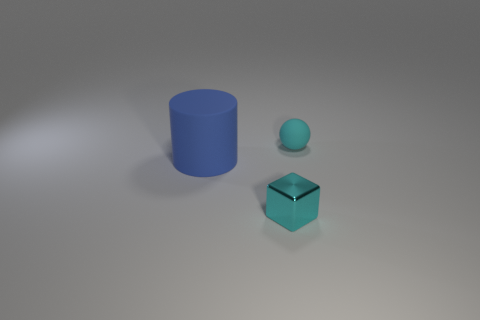How does the size of the blue cylinder compare to the other objects in the image? The blue cylinder is the largest object in the image, overshadowing the small turquoise cube and the even smaller blue sphere. 